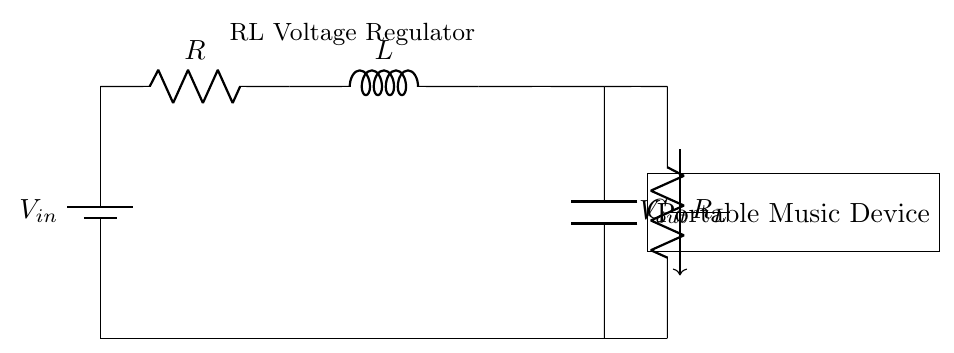What is the input voltage of this circuit? The input voltage is denoted as V_in, which represents the voltage supplied to the RL voltage regulator circuit.
Answer: V_in What type of load resistor is present in this circuit? The load resistor is labeled R_L, indicating that it is specifically for the load connected to the portable music device.
Answer: R_L What components are used in this RL voltage regulator? The components include a battery (V_in), a resistor (R), an inductor (L), a capacitor (C), and a load resistor (R_L) for the output.
Answer: Battery, Resistor, Inductor, Capacitor, Load Resistor How does the inductor contribute to the voltage regulation in this circuit? The inductor stores energy in its magnetic field when current flows, which helps to smooth out fluctuations in the voltage output, thus aiding in voltage regulation.
Answer: By smoothing voltage What happens to the output voltage when the input voltage increases? When V_in increases, the current through R and L also increases, leading to a change in the voltage across R_L, which can result in a higher V_out depending on the configuration.
Answer: V_out increases What is the purpose of the capacitor in this circuit? The capacitor is used to filter and smooth out any voltage variations at the output, helping to maintain a steady output voltage for the portable music device.
Answer: To filter voltage Is this type of circuit suitable for portable music devices? Yes, this RL-based voltage regulator design is suitable because it can provide stable voltage with minimal ripples for sensitive electronic devices like portable music players.
Answer: Yes 